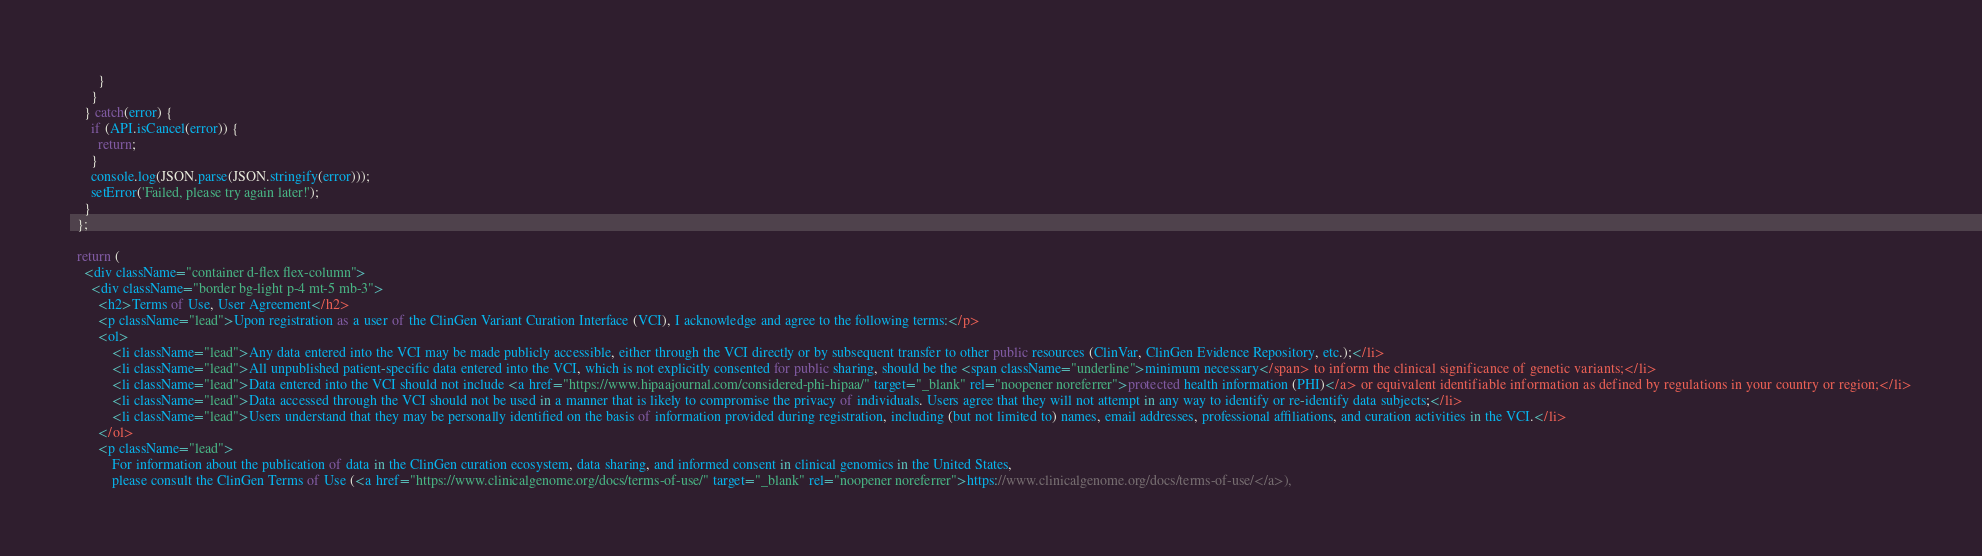Convert code to text. <code><loc_0><loc_0><loc_500><loc_500><_JavaScript_>        }
      }
    } catch(error) {
      if (API.isCancel(error)) {
        return;
      }
      console.log(JSON.parse(JSON.stringify(error)));
      setError('Failed, please try again later!');
    }
  };

  return (
    <div className="container d-flex flex-column">
      <div className="border bg-light p-4 mt-5 mb-3">
        <h2>Terms of Use, User Agreement</h2>
        <p className="lead">Upon registration as a user of the ClinGen Variant Curation Interface (VCI), I acknowledge and agree to the following terms:</p>
        <ol>
            <li className="lead">Any data entered into the VCI may be made publicly accessible, either through the VCI directly or by subsequent transfer to other public resources (ClinVar, ClinGen Evidence Repository, etc.);</li>
            <li className="lead">All unpublished patient-specific data entered into the VCI, which is not explicitly consented for public sharing, should be the <span className="underline">minimum necessary</span> to inform the clinical significance of genetic variants;</li>
            <li className="lead">Data entered into the VCI should not include <a href="https://www.hipaajournal.com/considered-phi-hipaa/" target="_blank" rel="noopener noreferrer">protected health information (PHI)</a> or equivalent identifiable information as defined by regulations in your country or region;</li>
            <li className="lead">Data accessed through the VCI should not be used in a manner that is likely to compromise the privacy of individuals. Users agree that they will not attempt in any way to identify or re-identify data subjects;</li>
            <li className="lead">Users understand that they may be personally identified on the basis of information provided during registration, including (but not limited to) names, email addresses, professional affiliations, and curation activities in the VCI.</li>
        </ol>
        <p className="lead">
            For information about the publication of data in the ClinGen curation ecosystem, data sharing, and informed consent in clinical genomics in the United States,
            please consult the ClinGen Terms of Use (<a href="https://www.clinicalgenome.org/docs/terms-of-use/" target="_blank" rel="noopener noreferrer">https://www.clinicalgenome.org/docs/terms-of-use/</a>),</code> 